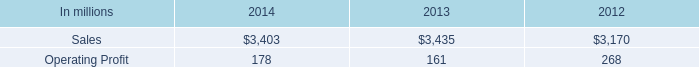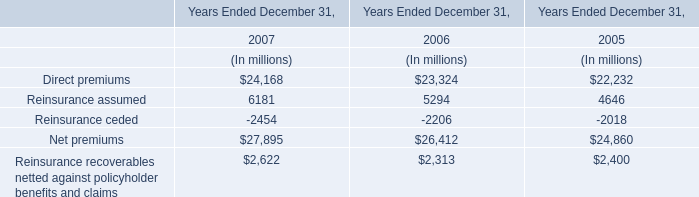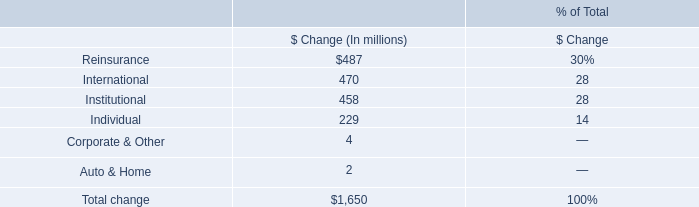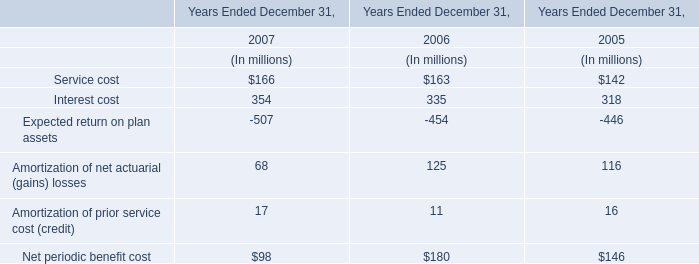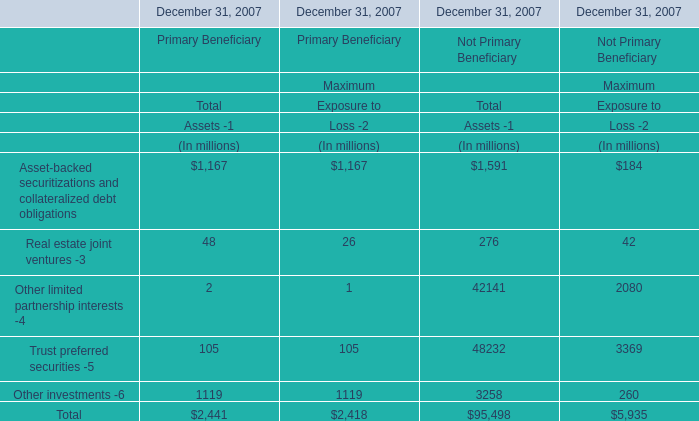What's the average of Maximum Exposure to Loss -2 in 2007? (in million) 
Computations: (2418 / 5)
Answer: 483.6. 